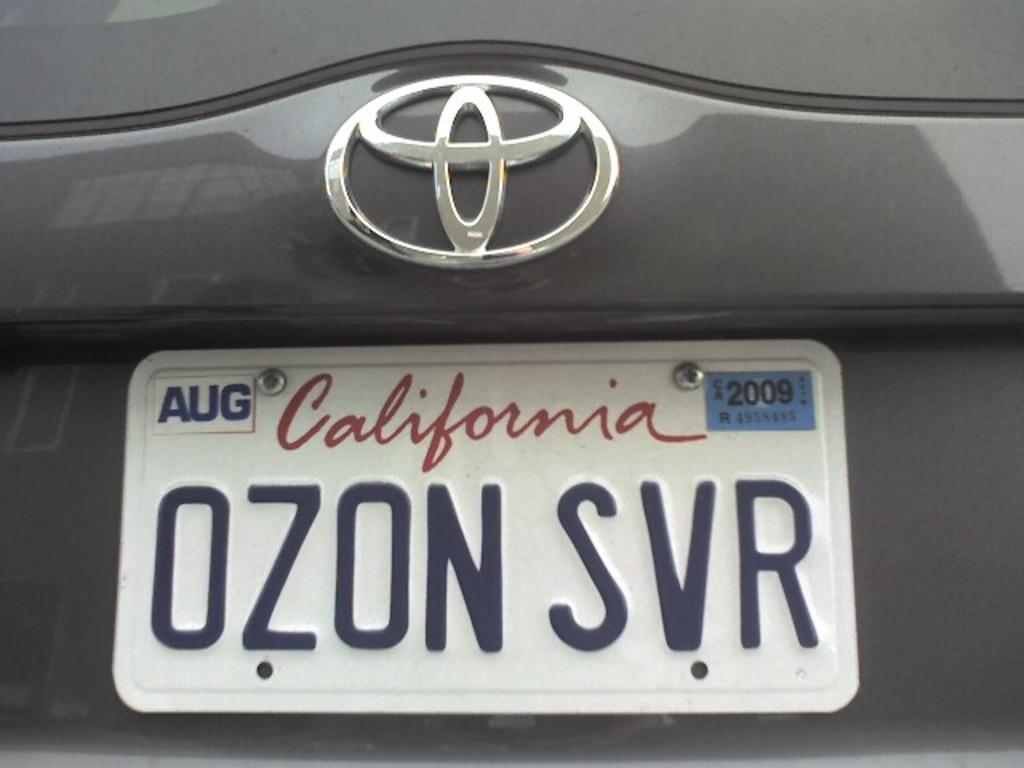What is the main subject of the image? The main subject of the image is a car. What feature of the car is mentioned in the facts? The car has a number plate. What additional detail is provided about the number plate? There is text on the number plate. What type of pest can be seen crawling on the car in the image? There is no pest visible on the car in the image. How much payment is required to use the car in the image? The image does not provide any information about payment or using the car. 